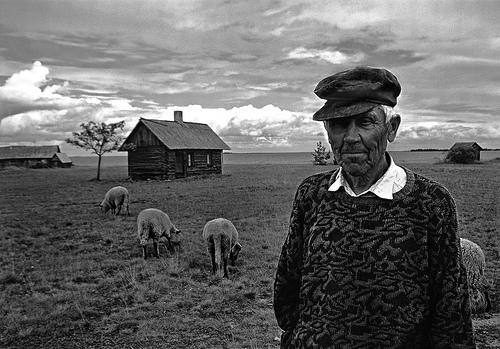What color is the shirt underneath of the old man's sweater?

Choices:
A) black
B) white
C) green
D) red white 